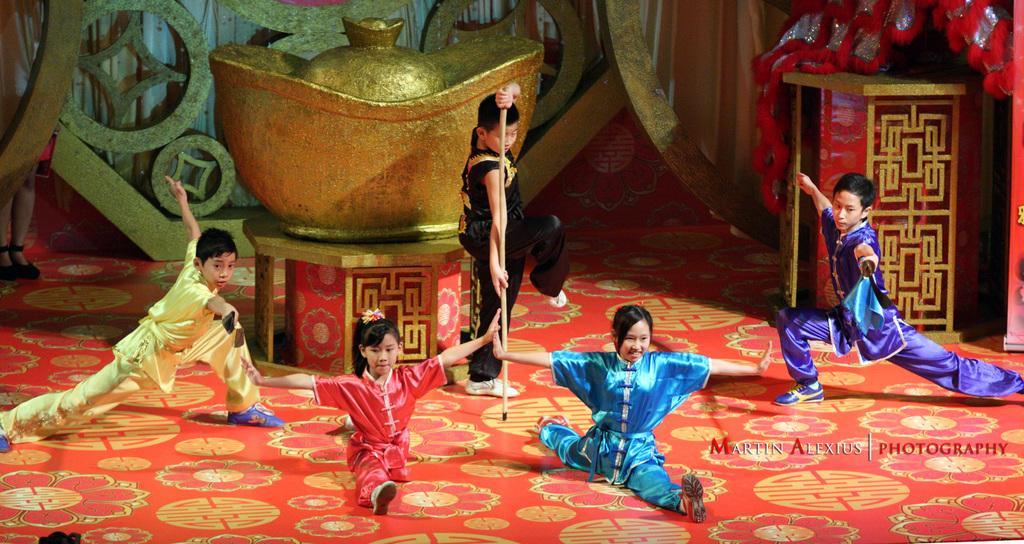In one or two sentences, can you explain what this image depicts? In this picture we can see three boys standing and two girls sitting on the floor and at the back of them we can see an object on a platform and in the background we can see a person standing. 